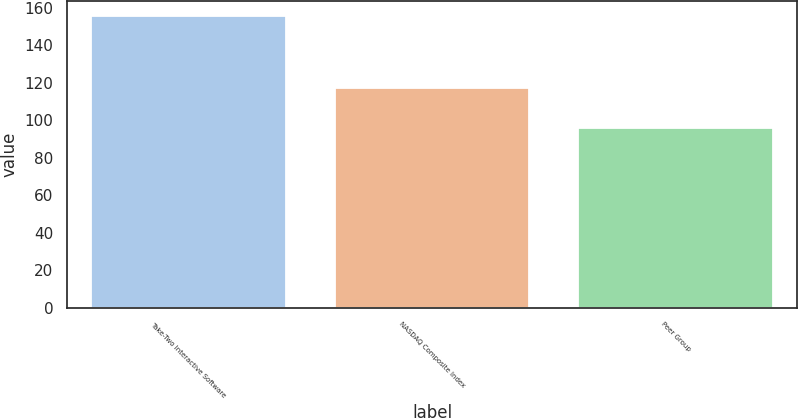Convert chart. <chart><loc_0><loc_0><loc_500><loc_500><bar_chart><fcel>Take-Two Interactive Software<fcel>NASDAQ Composite Index<fcel>Peer Group<nl><fcel>155.72<fcel>117.06<fcel>95.97<nl></chart> 